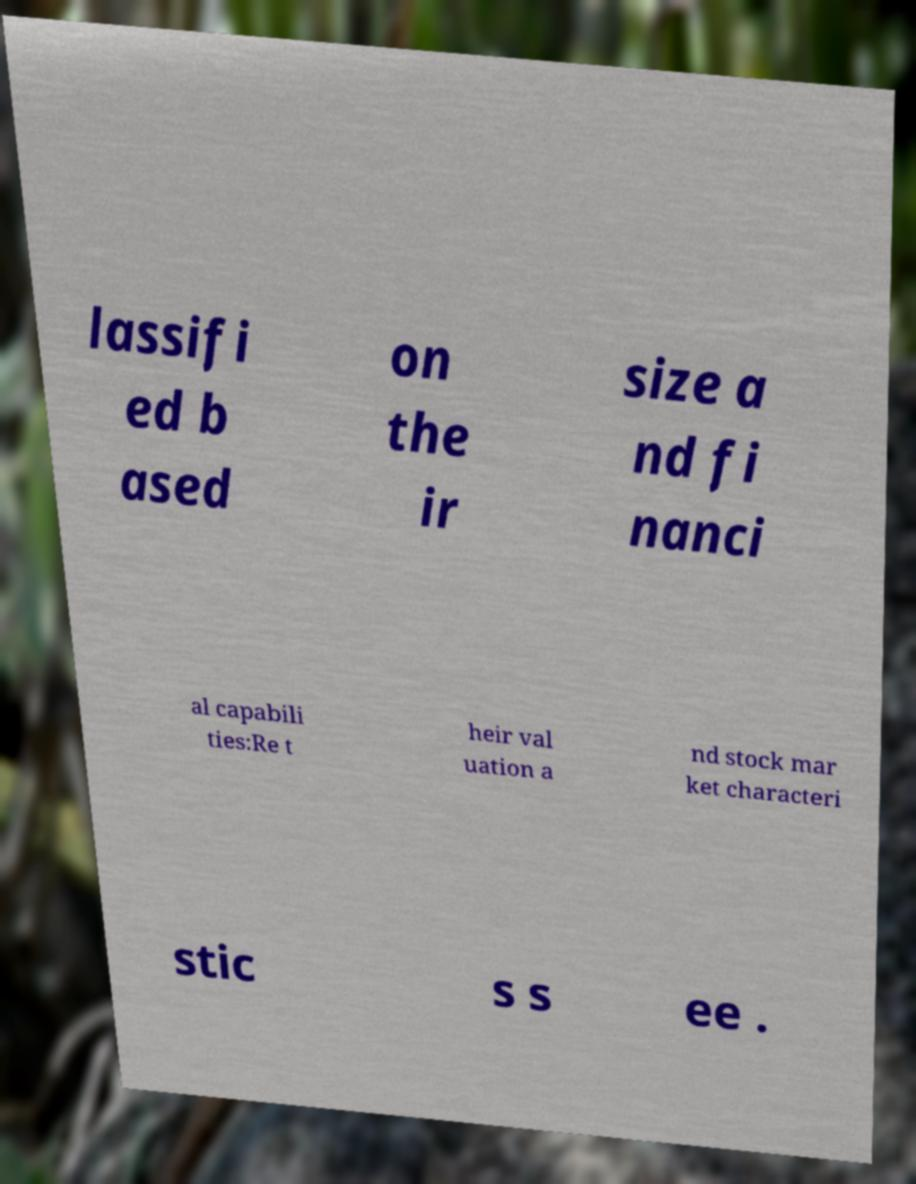Please read and relay the text visible in this image. What does it say? lassifi ed b ased on the ir size a nd fi nanci al capabili ties:Re t heir val uation a nd stock mar ket characteri stic s s ee . 